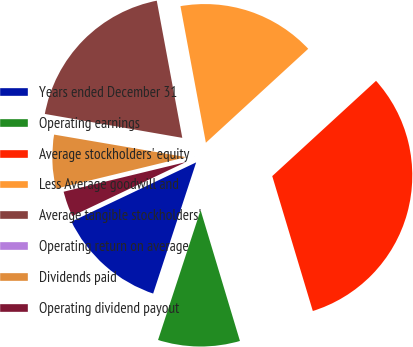Convert chart to OTSL. <chart><loc_0><loc_0><loc_500><loc_500><pie_chart><fcel>Years ended December 31<fcel>Operating earnings<fcel>Average stockholders' equity<fcel>Less Average goodwill and<fcel>Average tangible stockholders'<fcel>Operating return on average<fcel>Dividends paid<fcel>Operating dividend payout<nl><fcel>12.9%<fcel>9.69%<fcel>32.17%<fcel>16.11%<fcel>19.33%<fcel>0.05%<fcel>6.48%<fcel>3.27%<nl></chart> 